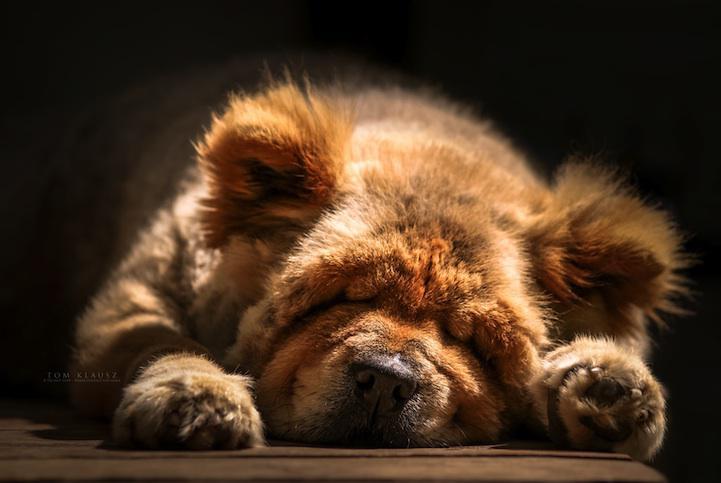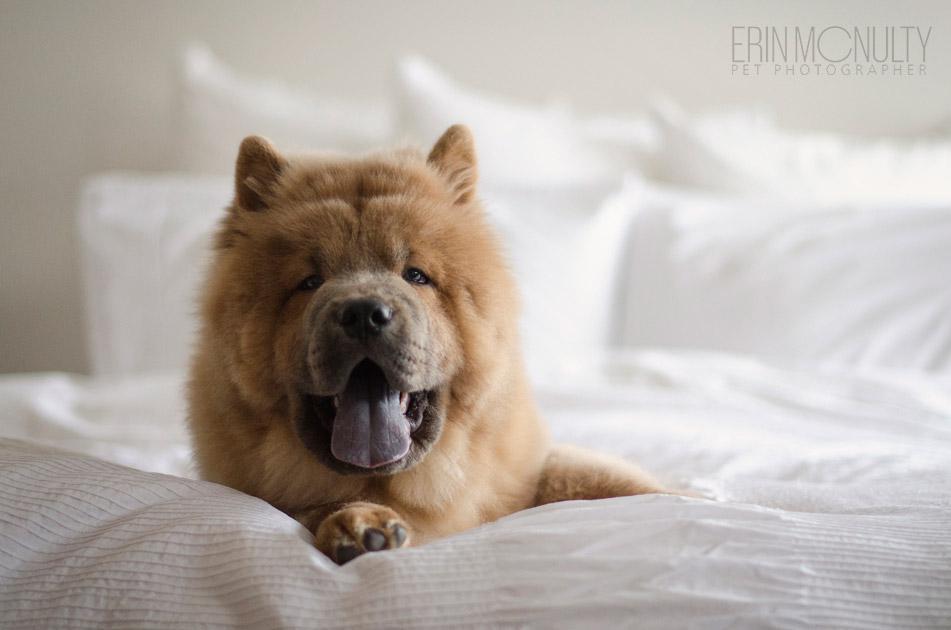The first image is the image on the left, the second image is the image on the right. Analyze the images presented: Is the assertion "In one of the image the dog is laying on a bed." valid? Answer yes or no. Yes. The first image is the image on the left, the second image is the image on the right. For the images displayed, is the sentence "All Chow dogs are on the grass." factually correct? Answer yes or no. No. 